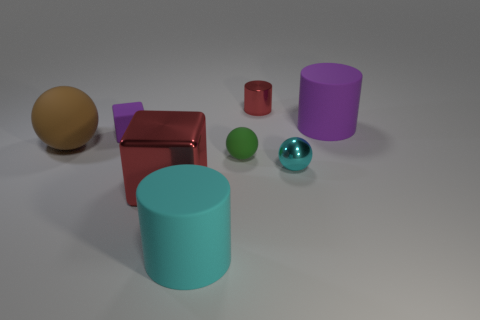What material is the red object that is on the left side of the large cylinder on the left side of the tiny shiny thing behind the big brown matte thing?
Give a very brief answer. Metal. What size is the cube that is made of the same material as the tiny cyan thing?
Offer a very short reply. Large. Is there anything else that is the same color as the shiny cube?
Give a very brief answer. Yes. There is a tiny thing that is left of the red cube; is it the same color as the large rubber thing that is behind the large brown matte ball?
Provide a short and direct response. Yes. What is the color of the tiny matte object in front of the tiny rubber cube?
Provide a short and direct response. Green. Is the size of the red object in front of the shiny cylinder the same as the tiny purple thing?
Give a very brief answer. No. Is the number of tiny blocks less than the number of small shiny things?
Your answer should be compact. Yes. The shiny thing that is the same color as the metal cylinder is what shape?
Your answer should be very brief. Cube. There is a big purple object; what number of small green matte objects are behind it?
Your response must be concise. 0. Does the green rubber thing have the same shape as the large cyan thing?
Give a very brief answer. No. 